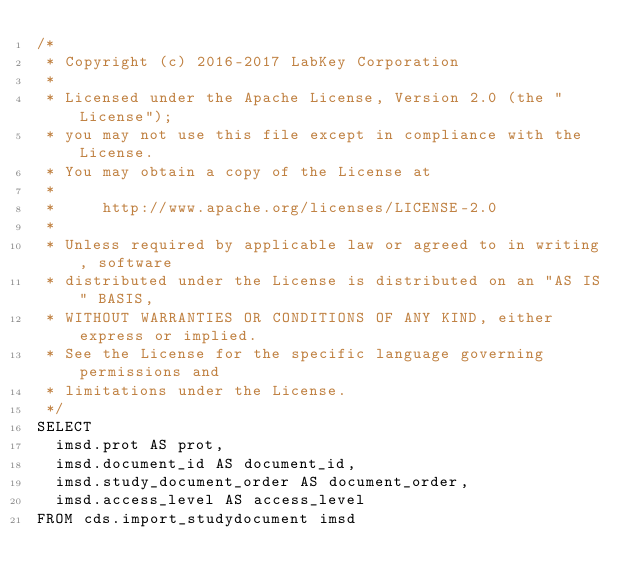Convert code to text. <code><loc_0><loc_0><loc_500><loc_500><_SQL_>/*
 * Copyright (c) 2016-2017 LabKey Corporation
 *
 * Licensed under the Apache License, Version 2.0 (the "License");
 * you may not use this file except in compliance with the License.
 * You may obtain a copy of the License at
 *
 *     http://www.apache.org/licenses/LICENSE-2.0
 *
 * Unless required by applicable law or agreed to in writing, software
 * distributed under the License is distributed on an "AS IS" BASIS,
 * WITHOUT WARRANTIES OR CONDITIONS OF ANY KIND, either express or implied.
 * See the License for the specific language governing permissions and
 * limitations under the License.
 */
SELECT
  imsd.prot AS prot,
  imsd.document_id AS document_id,
  imsd.study_document_order AS document_order,
  imsd.access_level AS access_level
FROM cds.import_studydocument imsd
</code> 